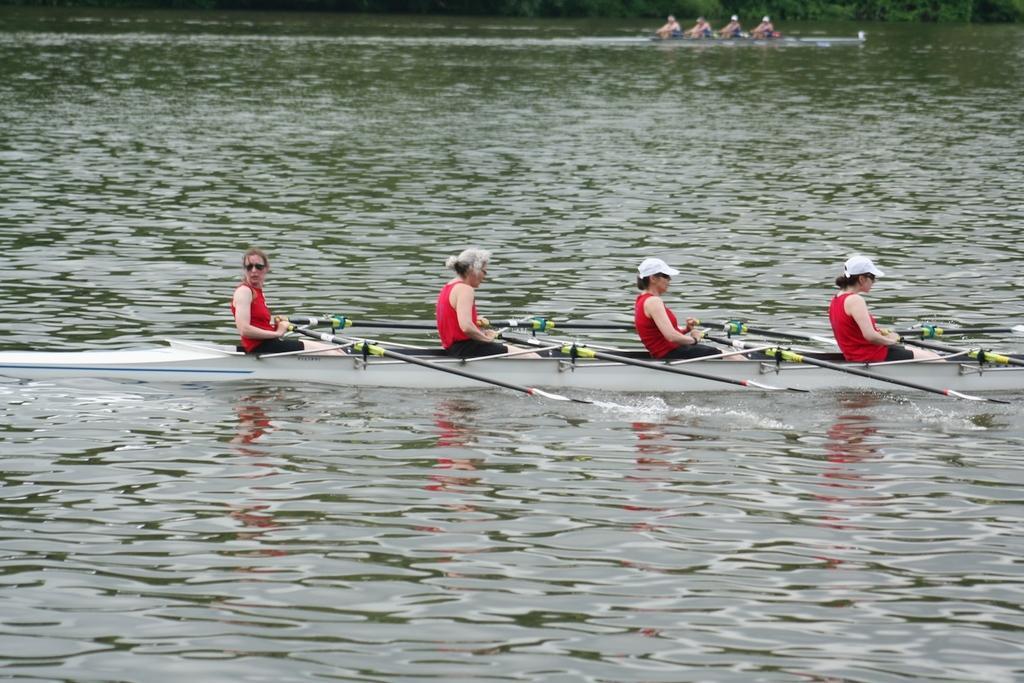In one or two sentences, can you explain what this image depicts? In this picture we can see some people are riding boats in the water. 